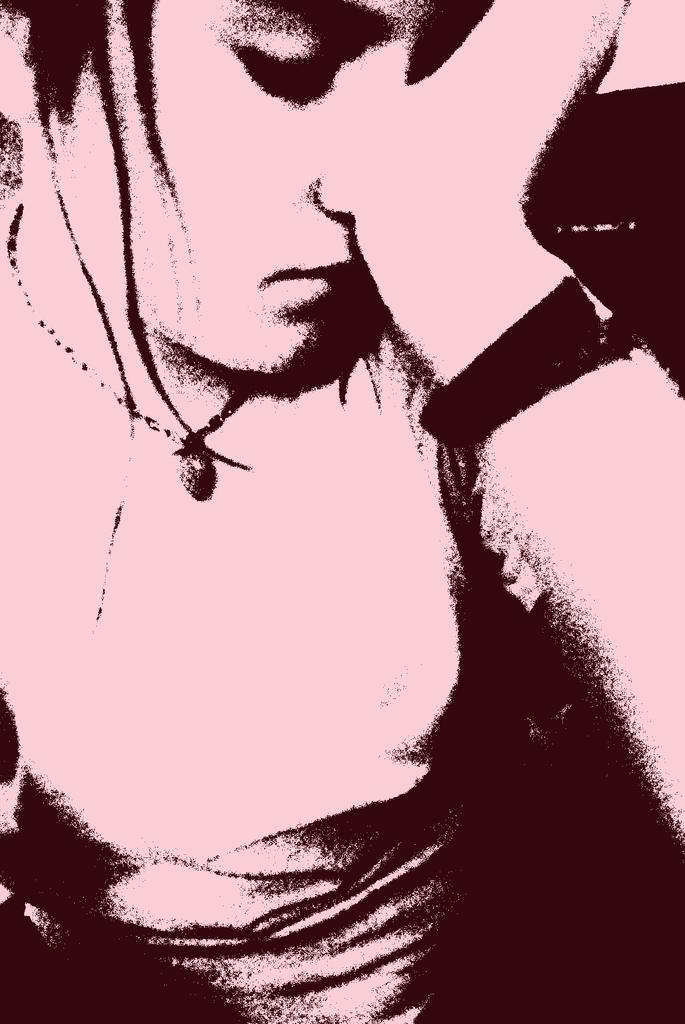Who or what is present in the image? There is a person in the image. What is the person doing in the image? The person is sitting. What country is visible in the background of the image? There is no country visible in the image, as it only features a person sitting. 